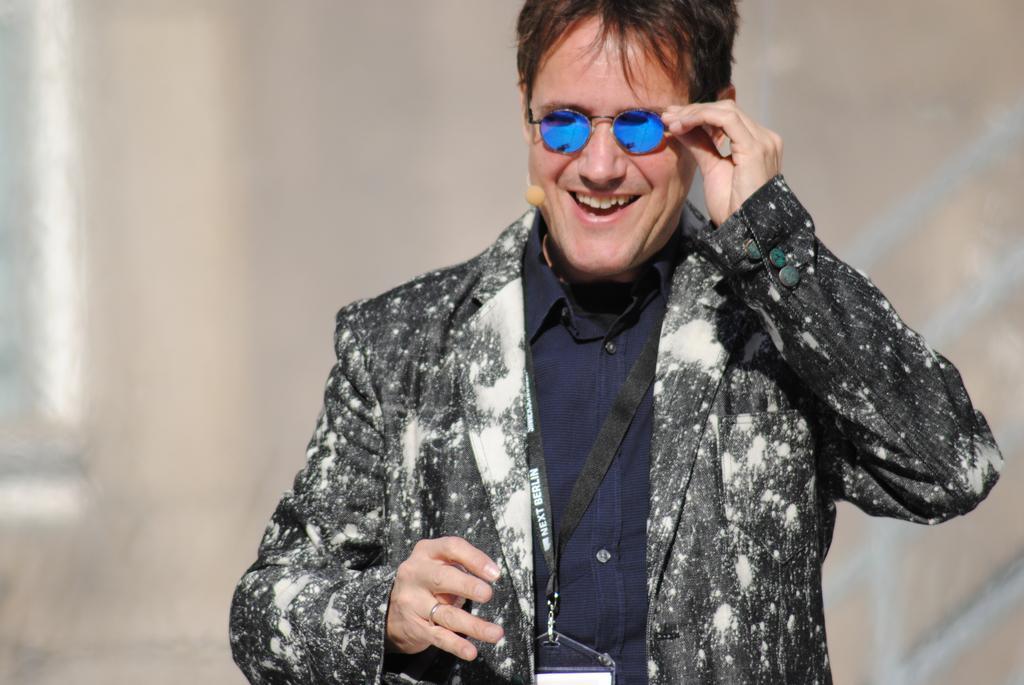How would you summarize this image in a sentence or two? In this picture we can see a person is smiling in the front, this person is wearing goggles, there is a blurry background. 